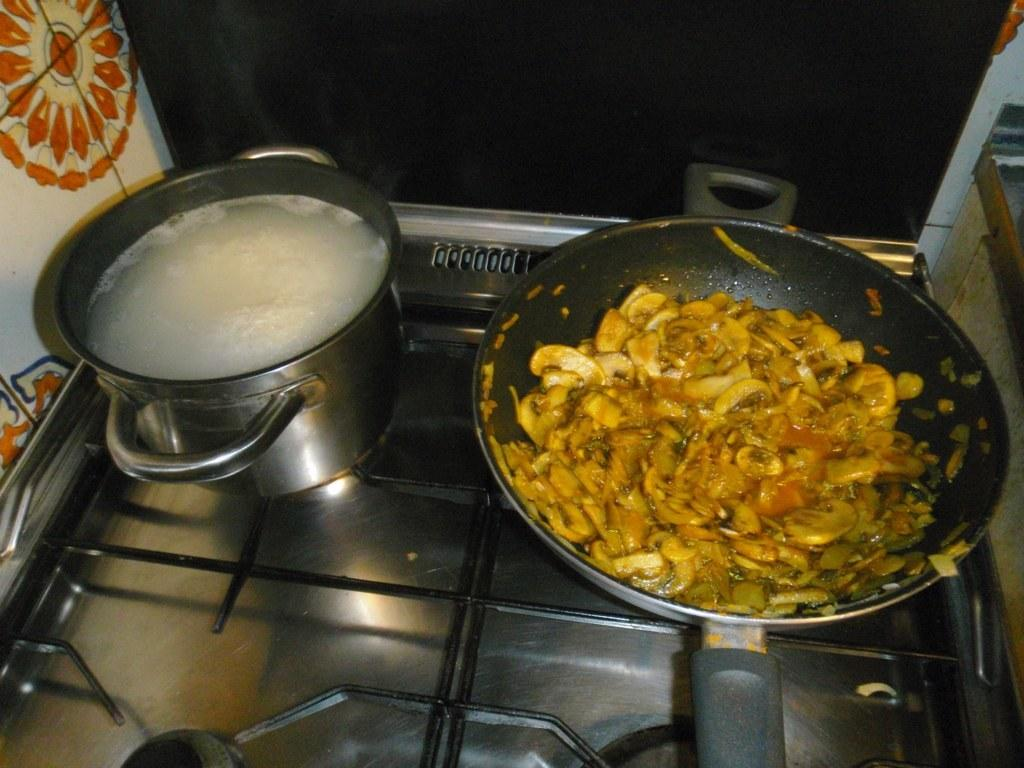What type of appliance is present in the picture? There is a stove in the picture. What can be found on the stove or near it? There are food items in bowls in the picture. What type of spy equipment can be seen on the stove in the image? There is no spy equipment present on the stove in the image. What type of book is placed on the stove in the image? There is no book present on the stove in the image. 